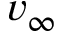<formula> <loc_0><loc_0><loc_500><loc_500>v _ { \infty }</formula> 